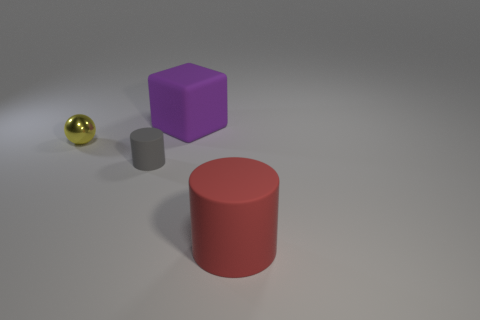Add 3 large red metallic blocks. How many objects exist? 7 Subtract all blocks. How many objects are left? 3 Add 4 purple blocks. How many purple blocks are left? 5 Add 2 small gray matte objects. How many small gray matte objects exist? 3 Subtract 0 purple balls. How many objects are left? 4 Subtract all big cylinders. Subtract all purple objects. How many objects are left? 2 